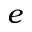<formula> <loc_0><loc_0><loc_500><loc_500>e</formula> 